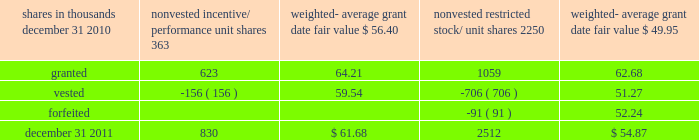There were no options granted in excess of market value in 2011 , 2010 or 2009 .
Shares of common stock available during the next year for the granting of options and other awards under the incentive plans were 33775543 at december 31 , 2011 .
Total shares of pnc common stock authorized for future issuance under equity compensation plans totaled 35304422 shares at december 31 , 2011 , which includes shares available for issuance under the incentive plans and the employee stock purchase plan ( espp ) as described below .
During 2011 , we issued 731336 shares from treasury stock in connection with stock option exercise activity .
As with past exercise activity , we currently intend to utilize primarily treasury stock for any future stock option exercises .
Awards granted to non-employee directors in 2011 , 2010 and 2009 include 27090 , 29040 , and 39552 deferred stock units , respectively , awarded under the outside directors deferred stock unit plan .
A deferred stock unit is a phantom share of our common stock , which requires liability accounting treatment until such awards are paid to the participants as cash .
As there are no vesting or service requirements on these awards , total compensation expense is recognized in full on awarded deferred stock units on the date of grant .
Incentive/performance unit share awards and restricted stock/unit awards the fair value of nonvested incentive/performance unit share awards and restricted stock/unit awards is initially determined based on prices not less than the market value of our common stock price on the date of grant .
The value of certain incentive/ performance unit share awards is subsequently remeasured based on the achievement of one or more financial and other performance goals generally over a three-year period .
The personnel and compensation committee of the board of directors approves the final award payout with respect to incentive/performance unit share awards .
Restricted stock/unit awards have various vesting periods generally ranging from 36 months to 60 months .
Beginning in 2011 , we incorporated two changes to certain awards under our existing long-term incentive compensation programs .
First , for certain grants of incentive performance units , the future payout amount will be subject to a negative annual adjustment if pnc fails to meet certain risk-related performance metrics .
This adjustment is in addition to the existing financial performance metrics relative to our peers .
These grants have a three-year performance period and are payable in either stock or a combination of stock and cash .
Second , performance-based restricted share units ( performance rsus ) were granted in 2011 to certain of our executives in lieu of stock options .
These performance rsus ( which are payable solely in stock ) have a service condition , an internal risk-related performance condition , and an external market condition .
Satisfaction of the performance condition is based on four independent one-year performance periods .
The weighted-average grant-date fair value of incentive/ performance unit share awards and restricted stock/unit awards granted in 2011 , 2010 and 2009 was $ 63.25 , $ 54.59 and $ 41.16 per share , respectively .
We recognize compensation expense for such awards ratably over the corresponding vesting and/or performance periods for each type of program .
Nonvested incentive/performance unit share awards and restricted stock/unit awards 2013 rollforward shares in thousands nonvested incentive/ performance unit shares weighted- average date fair nonvested restricted stock/ shares weighted- average date fair .
In the chart above , the unit shares and related weighted- average grant-date fair value of the incentive/performance awards exclude the effect of dividends on the underlying shares , as those dividends will be paid in cash .
At december 31 , 2011 , there was $ 61 million of unrecognized deferred compensation expense related to nonvested share- based compensation arrangements granted under the incentive plans .
This cost is expected to be recognized as expense over a period of no longer than five years .
The total fair value of incentive/performance unit share and restricted stock/unit awards vested during 2011 , 2010 and 2009 was approximately $ 52 million , $ 39 million and $ 47 million , respectively .
Liability awards we grant annually cash-payable restricted share units to certain executives .
The grants were made primarily as part of an annual bonus incentive deferral plan .
While there are time- based and service-related vesting criteria , there are no market or performance criteria associated with these awards .
Compensation expense recognized related to these awards was recorded in prior periods as part of annual cash bonus criteria .
As of december 31 , 2011 , there were 753203 of these cash- payable restricted share units outstanding .
174 the pnc financial services group , inc .
2013 form 10-k .
Were there more isos granted in the year than restricted stock units? 
Computations: (623 > 1059)
Answer: no. 